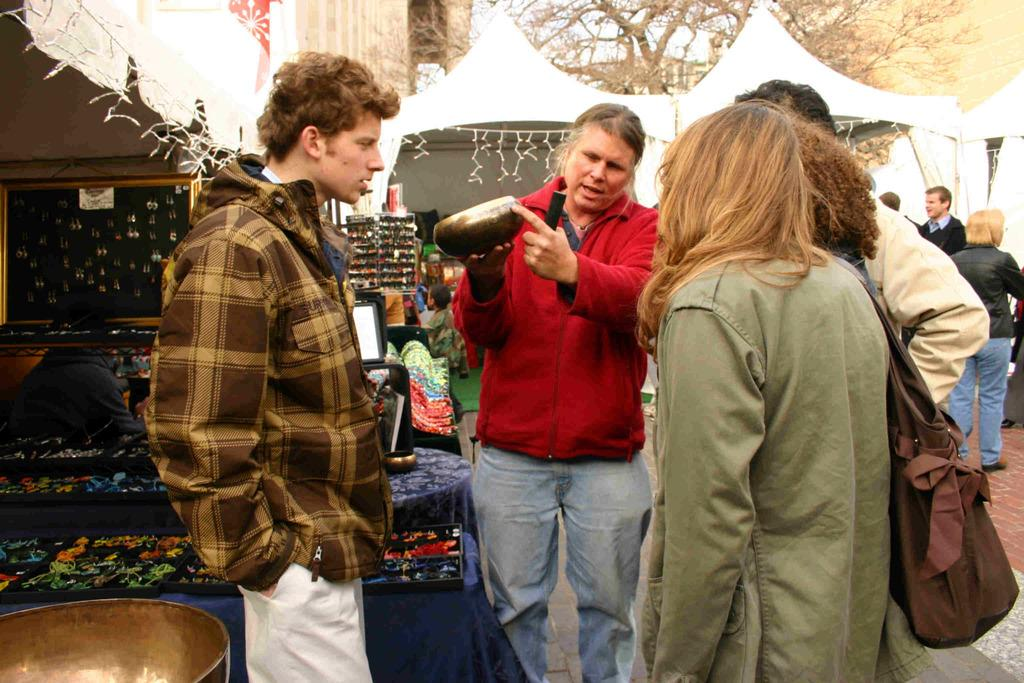What is happening in the image? There are people standing in the image, and a man is holding an object. Can you describe the object the man is holding? Unfortunately, the facts provided do not give a description of the object the man is holding. What type of structure is present in the image? There is a stall in the image. What can be seen in the background of the image? In the background, there are stalls visible, and people are present. What type of heart-shaped crate is visible in the image? There is no heart-shaped crate present in the image. What door leads to the area where the people are standing in the image? There is no door mentioned or visible in the image. 